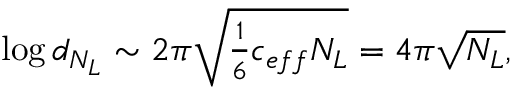<formula> <loc_0><loc_0><loc_500><loc_500>\log d _ { N _ { L } } \sim { 2 \pi \sqrt { \frac { 1 } { 6 } c _ { e f f } N _ { L } } } = 4 \pi \sqrt { N _ { L } } ,</formula> 